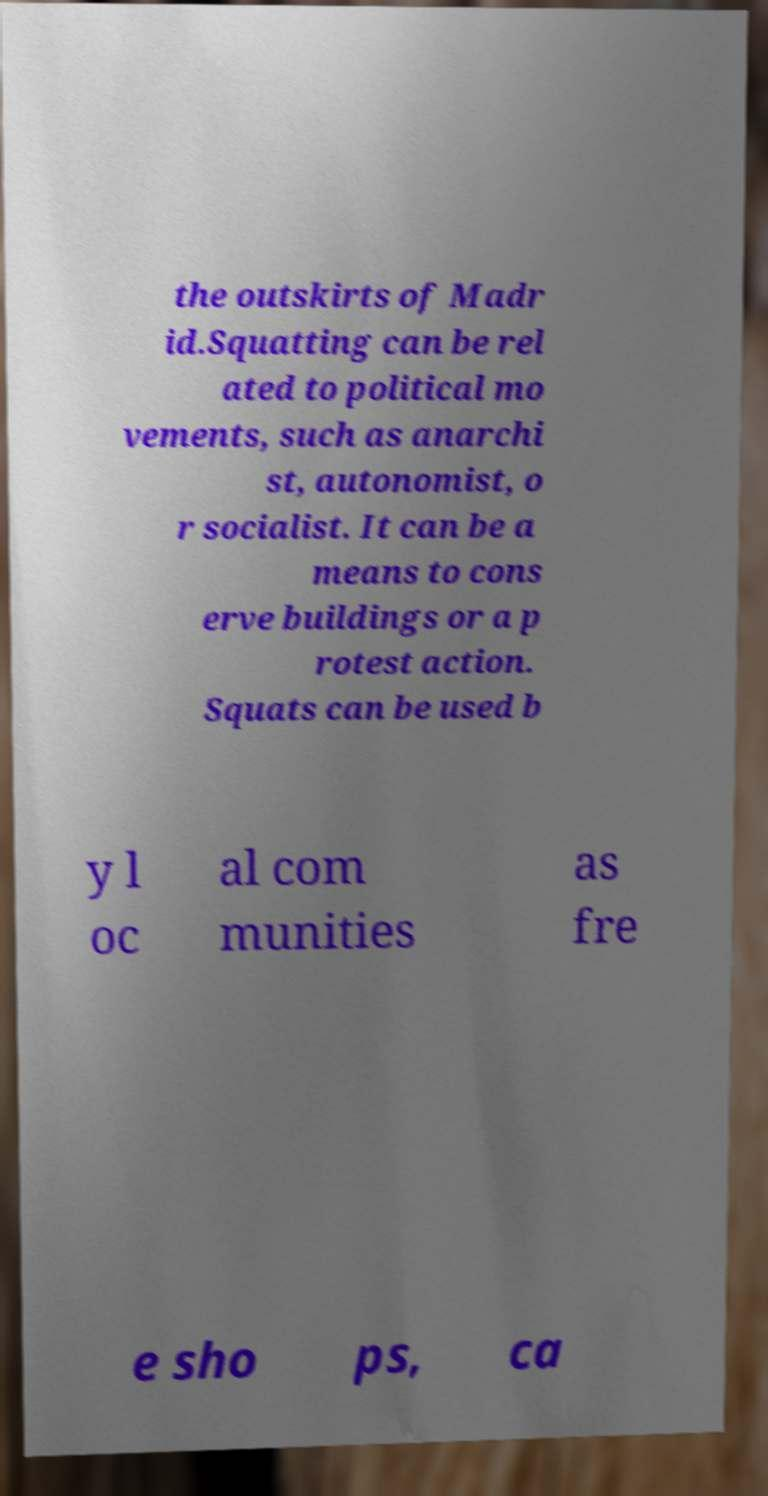Could you assist in decoding the text presented in this image and type it out clearly? the outskirts of Madr id.Squatting can be rel ated to political mo vements, such as anarchi st, autonomist, o r socialist. It can be a means to cons erve buildings or a p rotest action. Squats can be used b y l oc al com munities as fre e sho ps, ca 